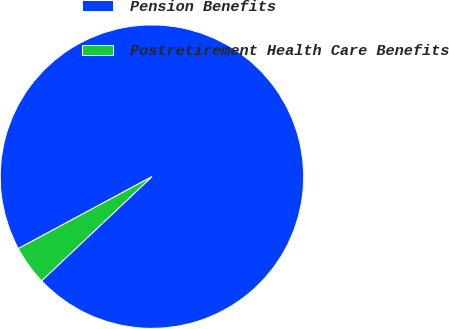Convert chart. <chart><loc_0><loc_0><loc_500><loc_500><pie_chart><fcel>Pension Benefits<fcel>Postretirement Health Care Benefits<nl><fcel>95.82%<fcel>4.18%<nl></chart> 